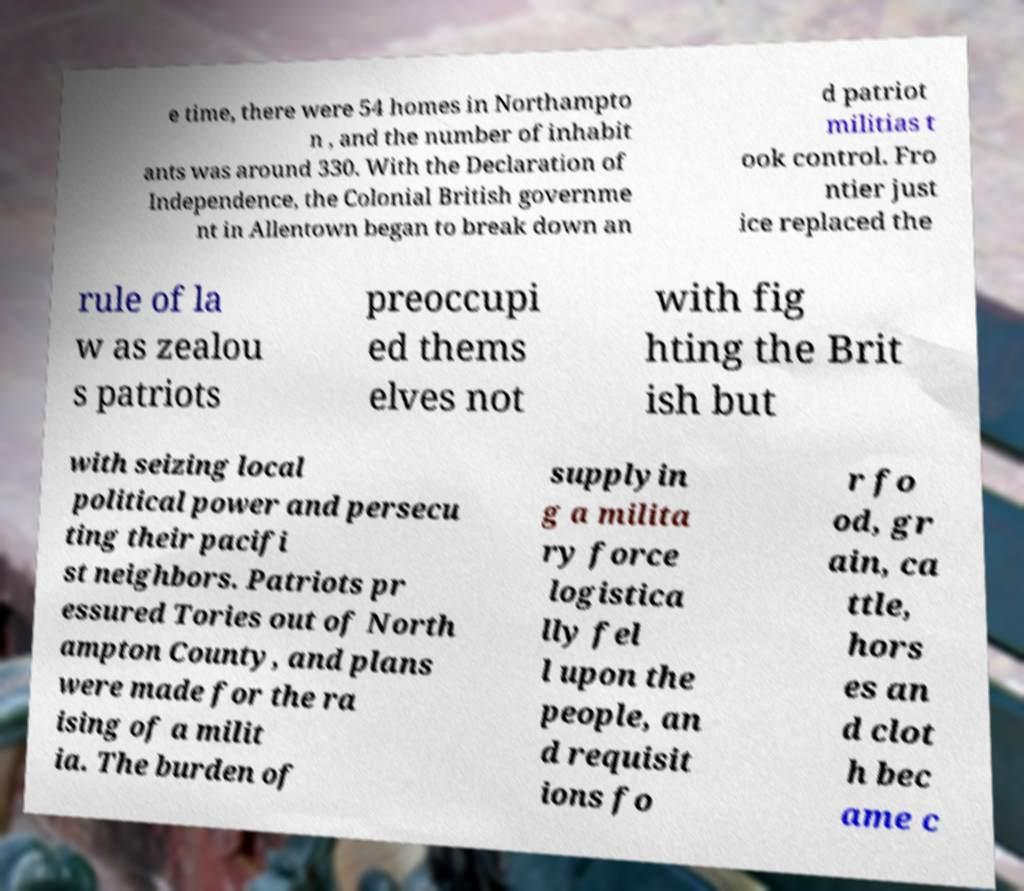Could you assist in decoding the text presented in this image and type it out clearly? e time, there were 54 homes in Northampto n , and the number of inhabit ants was around 330. With the Declaration of Independence, the Colonial British governme nt in Allentown began to break down an d patriot militias t ook control. Fro ntier just ice replaced the rule of la w as zealou s patriots preoccupi ed thems elves not with fig hting the Brit ish but with seizing local political power and persecu ting their pacifi st neighbors. Patriots pr essured Tories out of North ampton County, and plans were made for the ra ising of a milit ia. The burden of supplyin g a milita ry force logistica lly fel l upon the people, an d requisit ions fo r fo od, gr ain, ca ttle, hors es an d clot h bec ame c 